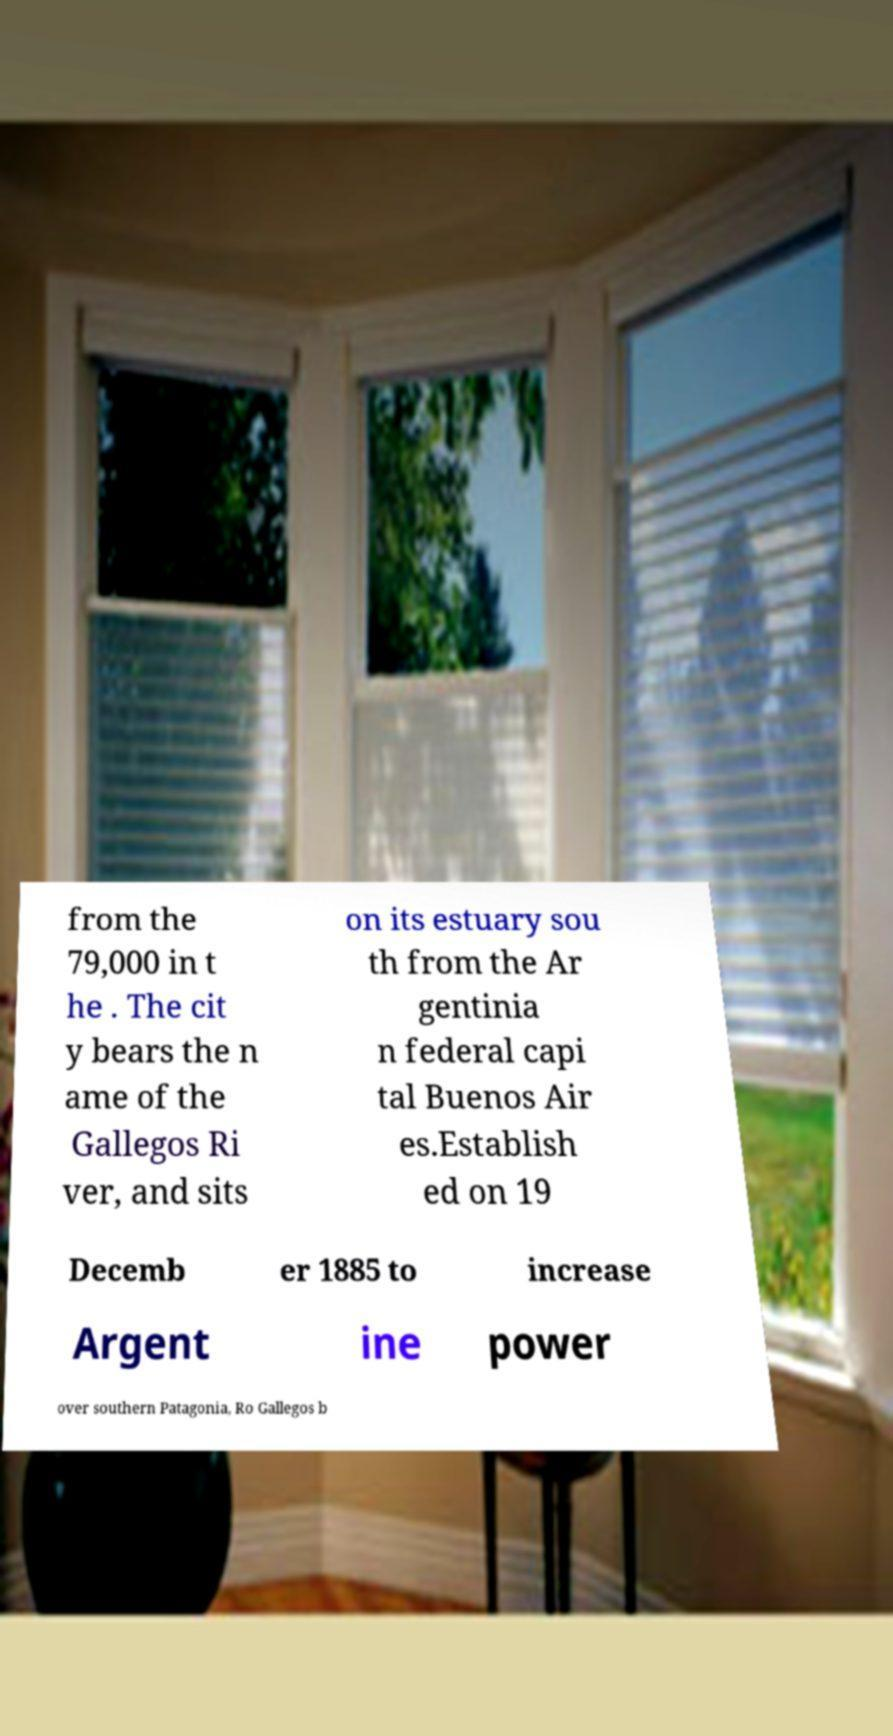For documentation purposes, I need the text within this image transcribed. Could you provide that? from the 79,000 in t he . The cit y bears the n ame of the Gallegos Ri ver, and sits on its estuary sou th from the Ar gentinia n federal capi tal Buenos Air es.Establish ed on 19 Decemb er 1885 to increase Argent ine power over southern Patagonia, Ro Gallegos b 